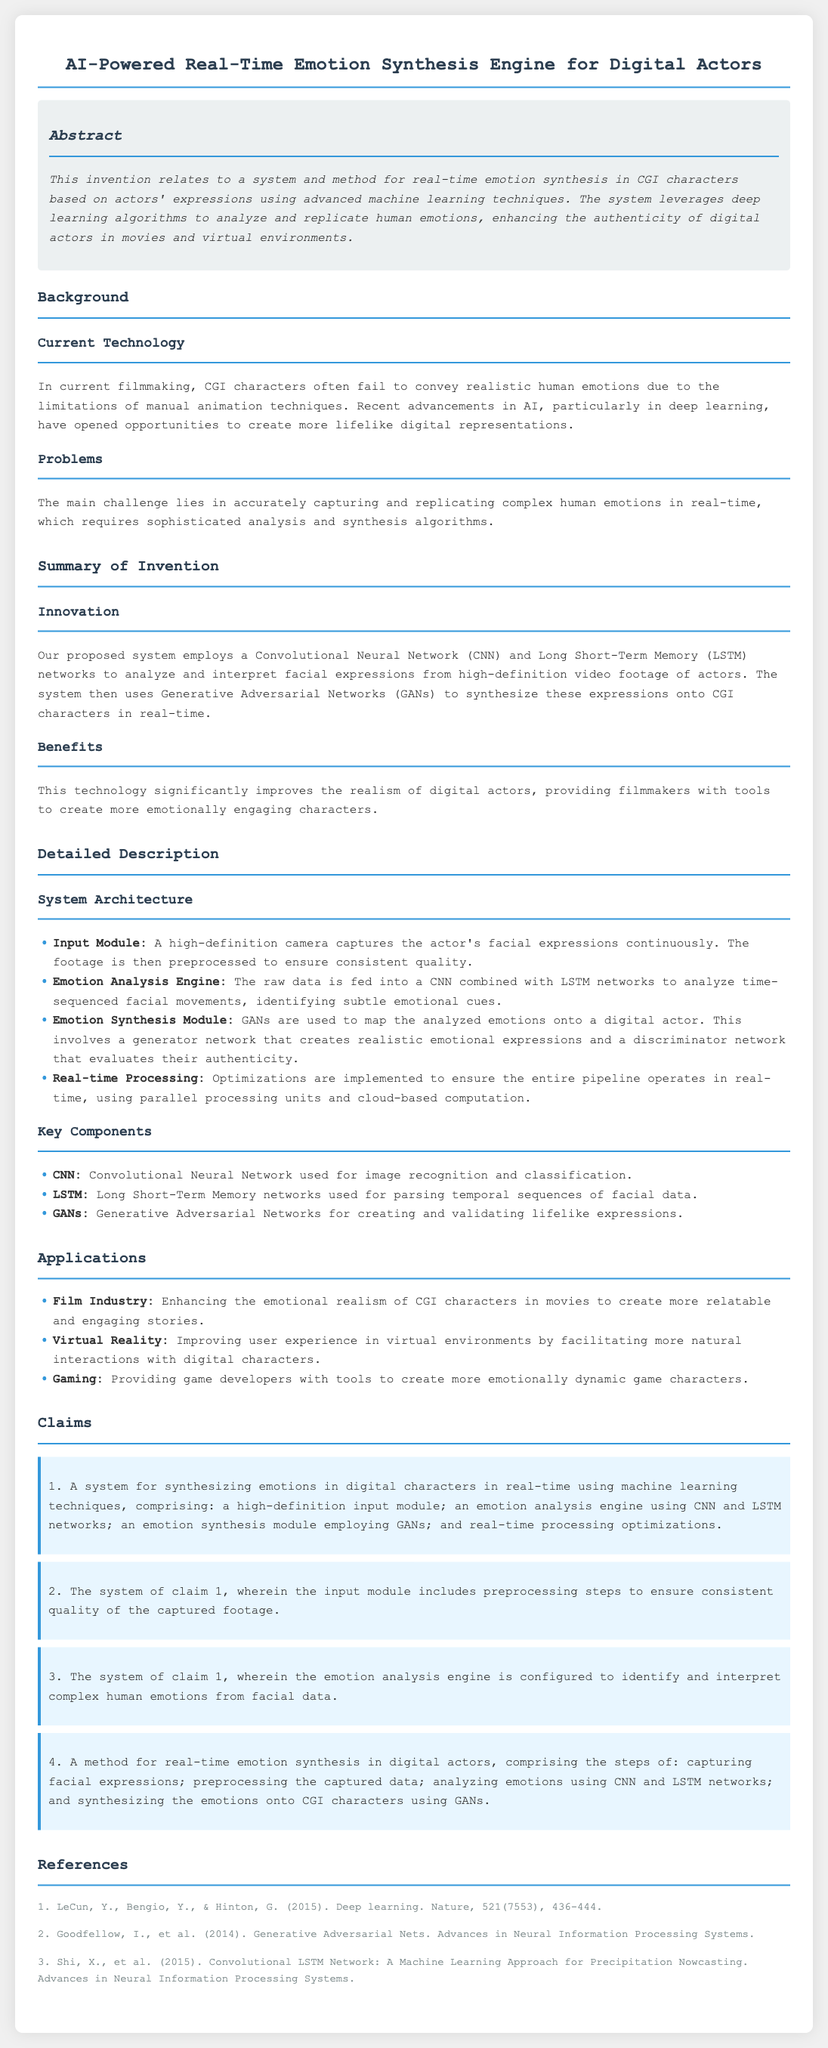what is the title of the patent application? The title of the patent application is presented at the top of the document.
Answer: AI-Powered Real-Time Emotion Synthesis Engine for Digital Actors what technology is primarily used for emotion analysis in the system? The document specifies that a Convolutional Neural Network is utilized for emotion analysis.
Answer: CNN which industry is highlighted as a key application for this technology? The document lists several applications and one is specifically mentioned first.
Answer: Film Industry how many key components are listed in the Detailed Description? The section includes a list of key components which are explicitly numbered.
Answer: Three what is the first step in the method for real-time emotion synthesis? The document describes a method with listed steps, indicating capturing as the first action.
Answer: Capturing facial expressions which deep learning architecture is used for synthesizing emotions? The document specifies a particular architecture used for the synthesis process.
Answer: GANs who are the authors referenced for the concept of Generative Adversarial Nets? The names of the authors are provided in the References section, specifically for this concept.
Answer: Goodfellow, I., et al what is the purpose of preprocessing in the Input Module? The document states that preprocessing ensures a specific aspect related to the quality of captured footage.
Answer: Consistent quality how many claims are included in the Claims section? The claims section presents a set of items, which can be counted.
Answer: Four 